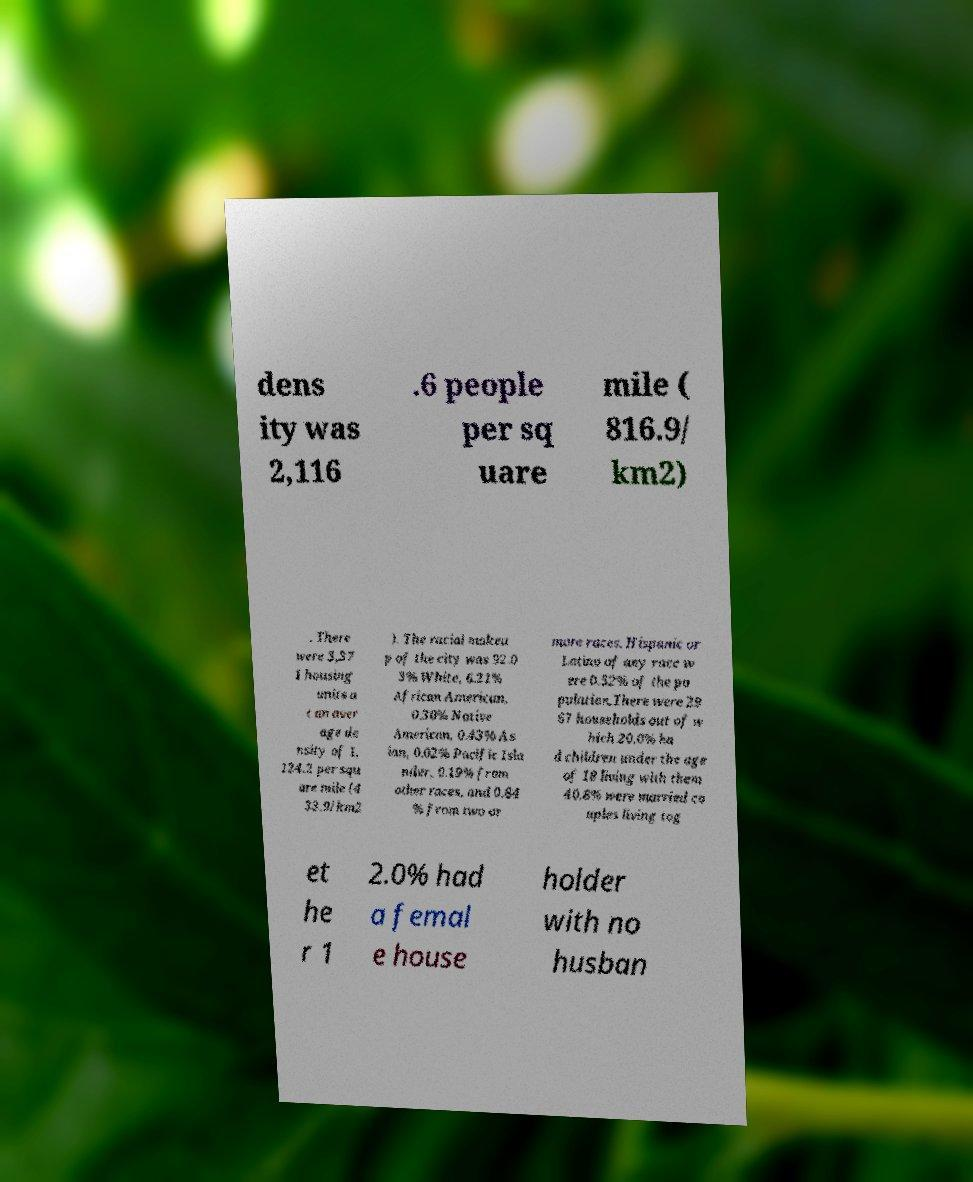Can you accurately transcribe the text from the provided image for me? dens ity was 2,116 .6 people per sq uare mile ( 816.9/ km2) . There were 3,37 1 housing units a t an aver age de nsity of 1, 124.2 per squ are mile (4 33.9/km2 ). The racial makeu p of the city was 92.0 3% White, 6.21% African American, 0.30% Native American, 0.43% As ian, 0.02% Pacific Isla nder, 0.19% from other races, and 0.84 % from two or more races. Hispanic or Latino of any race w ere 0.52% of the po pulation.There were 29 67 households out of w hich 20.0% ha d children under the age of 18 living with them 40.8% were married co uples living tog et he r 1 2.0% had a femal e house holder with no husban 